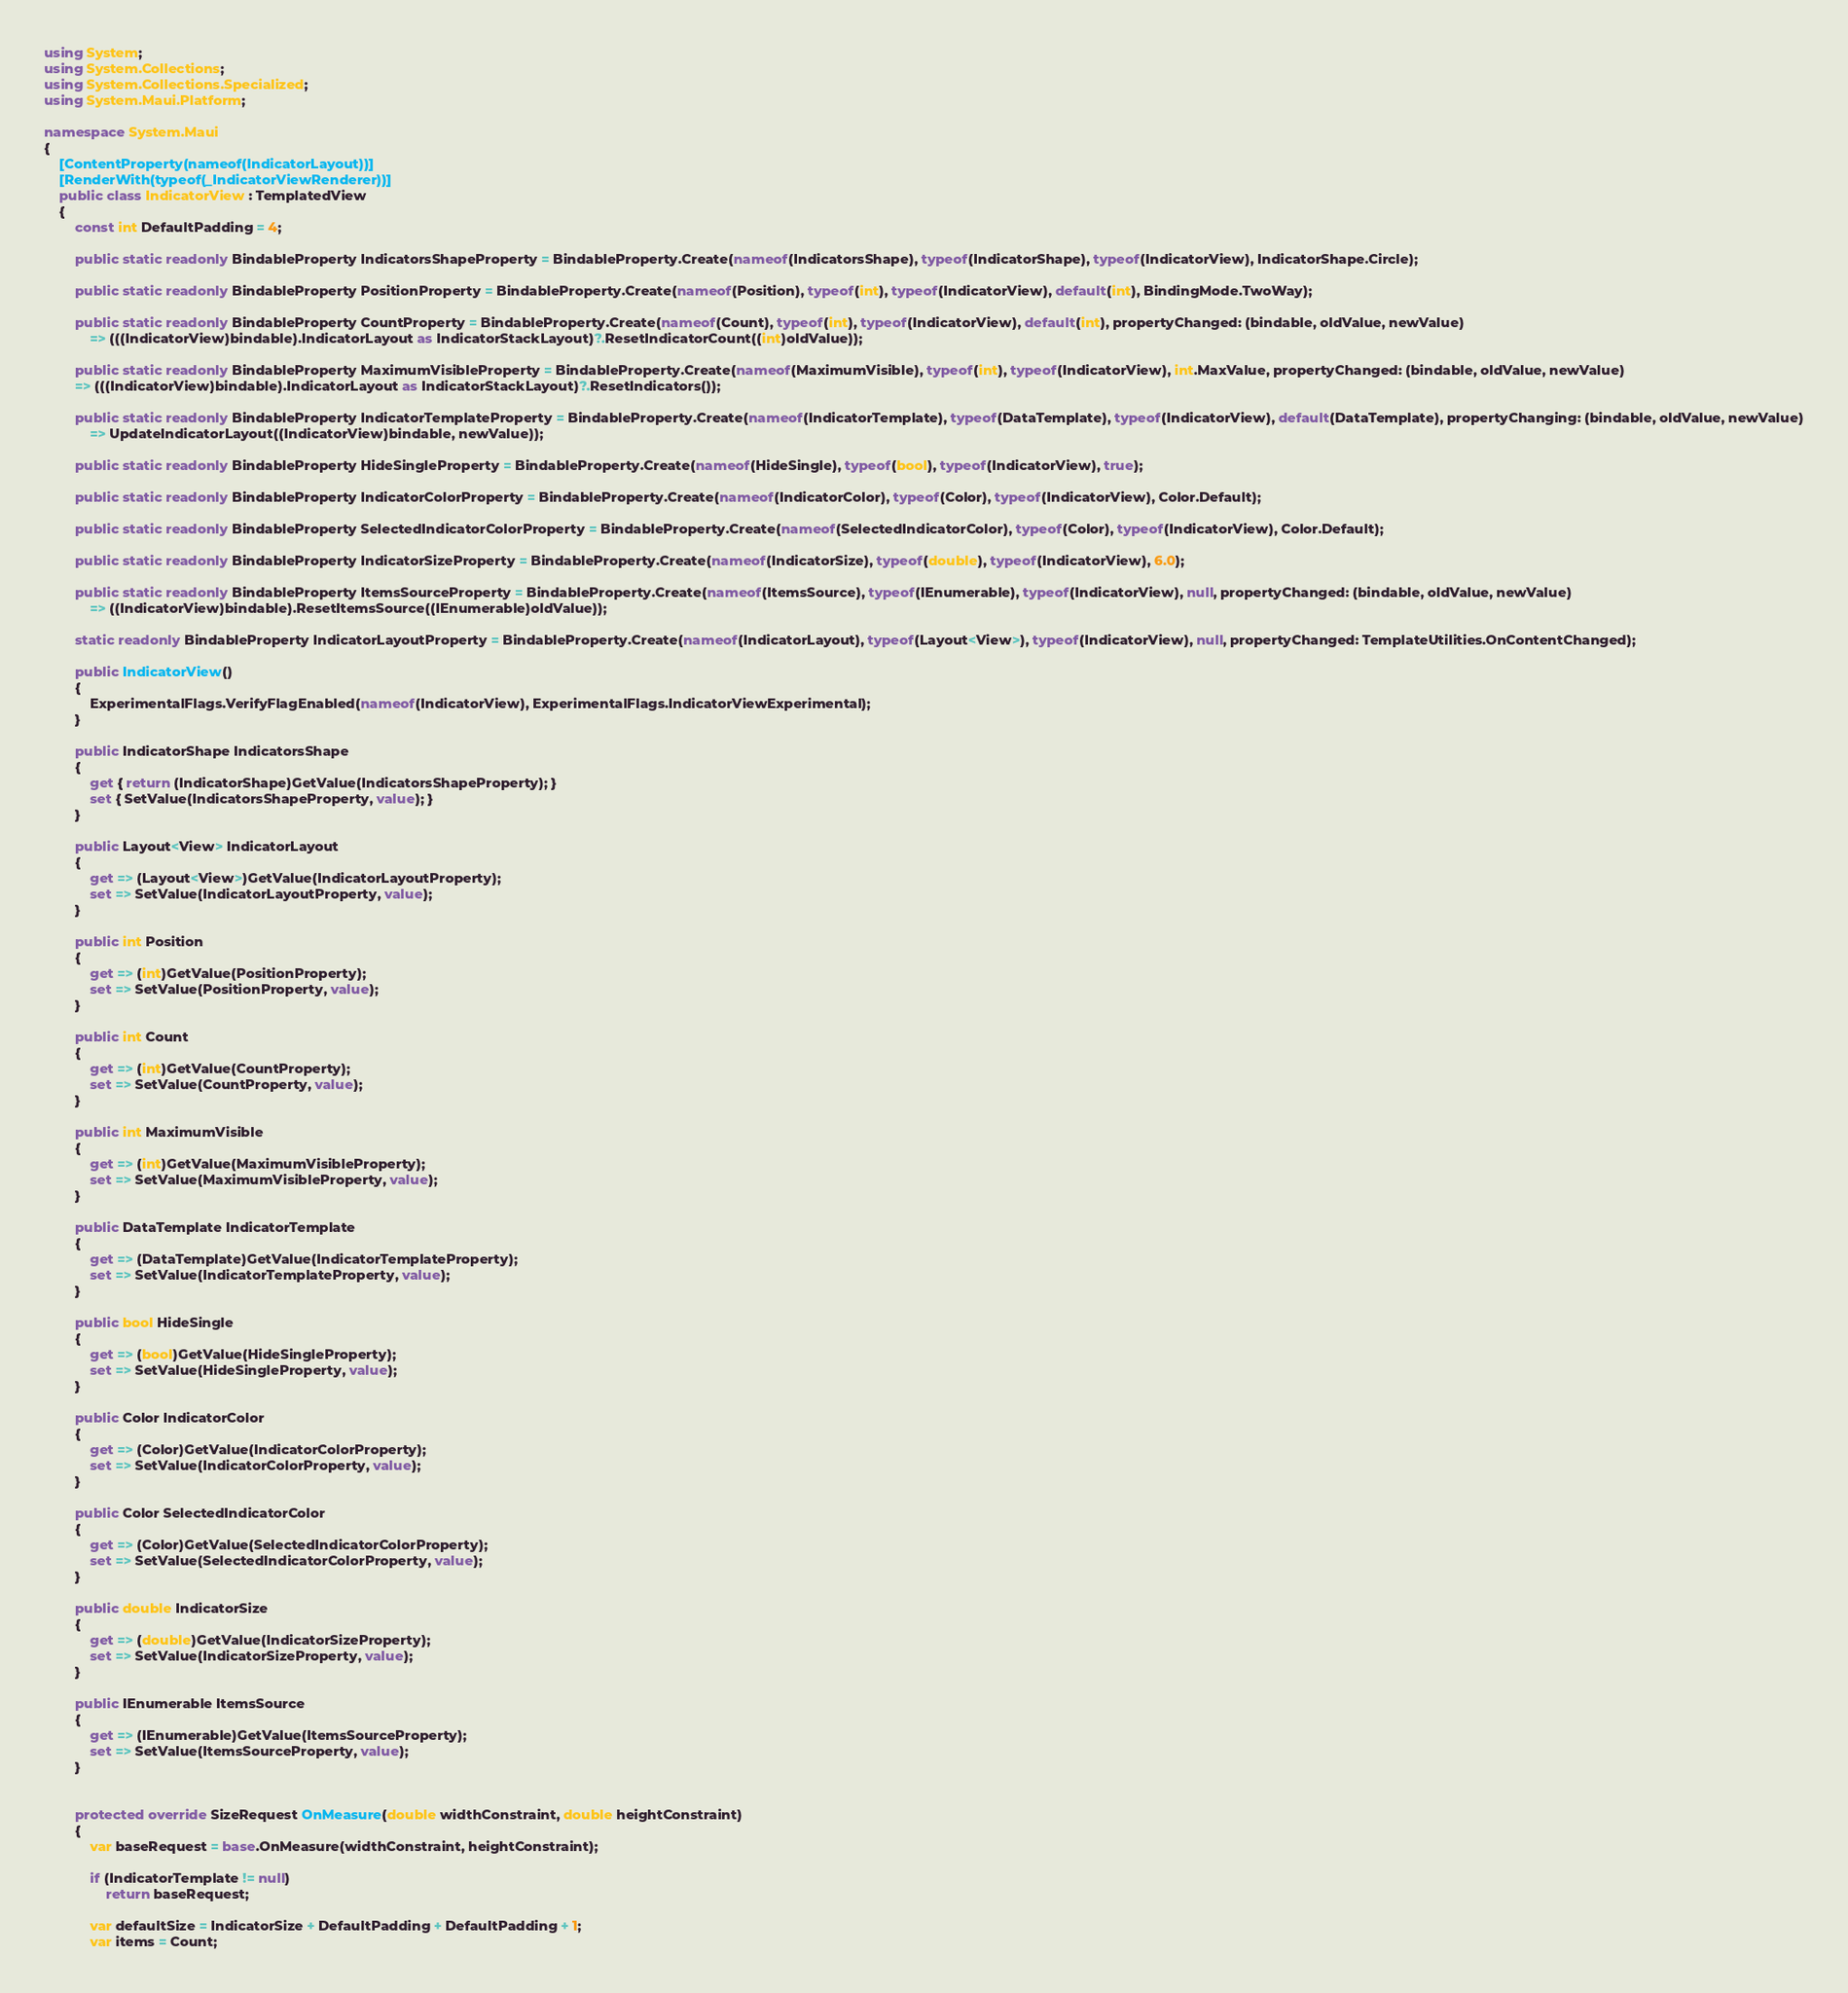<code> <loc_0><loc_0><loc_500><loc_500><_C#_>using System;
using System.Collections;
using System.Collections.Specialized;
using System.Maui.Platform;

namespace System.Maui
{
	[ContentProperty(nameof(IndicatorLayout))]
	[RenderWith(typeof(_IndicatorViewRenderer))]
	public class IndicatorView : TemplatedView
	{
		const int DefaultPadding = 4;

		public static readonly BindableProperty IndicatorsShapeProperty = BindableProperty.Create(nameof(IndicatorsShape), typeof(IndicatorShape), typeof(IndicatorView), IndicatorShape.Circle);

		public static readonly BindableProperty PositionProperty = BindableProperty.Create(nameof(Position), typeof(int), typeof(IndicatorView), default(int), BindingMode.TwoWay);

		public static readonly BindableProperty CountProperty = BindableProperty.Create(nameof(Count), typeof(int), typeof(IndicatorView), default(int), propertyChanged: (bindable, oldValue, newValue)
			=> (((IndicatorView)bindable).IndicatorLayout as IndicatorStackLayout)?.ResetIndicatorCount((int)oldValue));

		public static readonly BindableProperty MaximumVisibleProperty = BindableProperty.Create(nameof(MaximumVisible), typeof(int), typeof(IndicatorView), int.MaxValue, propertyChanged: (bindable, oldValue, newValue)
		=> (((IndicatorView)bindable).IndicatorLayout as IndicatorStackLayout)?.ResetIndicators());

		public static readonly BindableProperty IndicatorTemplateProperty = BindableProperty.Create(nameof(IndicatorTemplate), typeof(DataTemplate), typeof(IndicatorView), default(DataTemplate), propertyChanging: (bindable, oldValue, newValue)
			=> UpdateIndicatorLayout((IndicatorView)bindable, newValue));

		public static readonly BindableProperty HideSingleProperty = BindableProperty.Create(nameof(HideSingle), typeof(bool), typeof(IndicatorView), true);

		public static readonly BindableProperty IndicatorColorProperty = BindableProperty.Create(nameof(IndicatorColor), typeof(Color), typeof(IndicatorView), Color.Default);

		public static readonly BindableProperty SelectedIndicatorColorProperty = BindableProperty.Create(nameof(SelectedIndicatorColor), typeof(Color), typeof(IndicatorView), Color.Default);

		public static readonly BindableProperty IndicatorSizeProperty = BindableProperty.Create(nameof(IndicatorSize), typeof(double), typeof(IndicatorView), 6.0);

		public static readonly BindableProperty ItemsSourceProperty = BindableProperty.Create(nameof(ItemsSource), typeof(IEnumerable), typeof(IndicatorView), null, propertyChanged: (bindable, oldValue, newValue)
			=> ((IndicatorView)bindable).ResetItemsSource((IEnumerable)oldValue));

		static readonly BindableProperty IndicatorLayoutProperty = BindableProperty.Create(nameof(IndicatorLayout), typeof(Layout<View>), typeof(IndicatorView), null, propertyChanged: TemplateUtilities.OnContentChanged);

		public IndicatorView()
		{
			ExperimentalFlags.VerifyFlagEnabled(nameof(IndicatorView), ExperimentalFlags.IndicatorViewExperimental);
		}

		public IndicatorShape IndicatorsShape
		{
			get { return (IndicatorShape)GetValue(IndicatorsShapeProperty); }
			set { SetValue(IndicatorsShapeProperty, value); }
		}

		public Layout<View> IndicatorLayout
		{
			get => (Layout<View>)GetValue(IndicatorLayoutProperty);
			set => SetValue(IndicatorLayoutProperty, value);
		}

		public int Position
		{
			get => (int)GetValue(PositionProperty);
			set => SetValue(PositionProperty, value);
		}

		public int Count
		{
			get => (int)GetValue(CountProperty);
			set => SetValue(CountProperty, value);
		}

		public int MaximumVisible
		{
			get => (int)GetValue(MaximumVisibleProperty);
			set => SetValue(MaximumVisibleProperty, value);
		}

		public DataTemplate IndicatorTemplate
		{
			get => (DataTemplate)GetValue(IndicatorTemplateProperty);
			set => SetValue(IndicatorTemplateProperty, value);
		}

		public bool HideSingle
		{
			get => (bool)GetValue(HideSingleProperty);
			set => SetValue(HideSingleProperty, value);
		}

		public Color IndicatorColor
		{
			get => (Color)GetValue(IndicatorColorProperty);
			set => SetValue(IndicatorColorProperty, value);
		}

		public Color SelectedIndicatorColor
		{
			get => (Color)GetValue(SelectedIndicatorColorProperty);
			set => SetValue(SelectedIndicatorColorProperty, value);
		}

		public double IndicatorSize
		{
			get => (double)GetValue(IndicatorSizeProperty);
			set => SetValue(IndicatorSizeProperty, value);
		}

		public IEnumerable ItemsSource
		{
			get => (IEnumerable)GetValue(ItemsSourceProperty);
			set => SetValue(ItemsSourceProperty, value);
		}


		protected override SizeRequest OnMeasure(double widthConstraint, double heightConstraint)
		{
			var baseRequest = base.OnMeasure(widthConstraint, heightConstraint);

			if (IndicatorTemplate != null)
				return baseRequest;

			var defaultSize = IndicatorSize + DefaultPadding + DefaultPadding + 1;
			var items = Count;</code> 